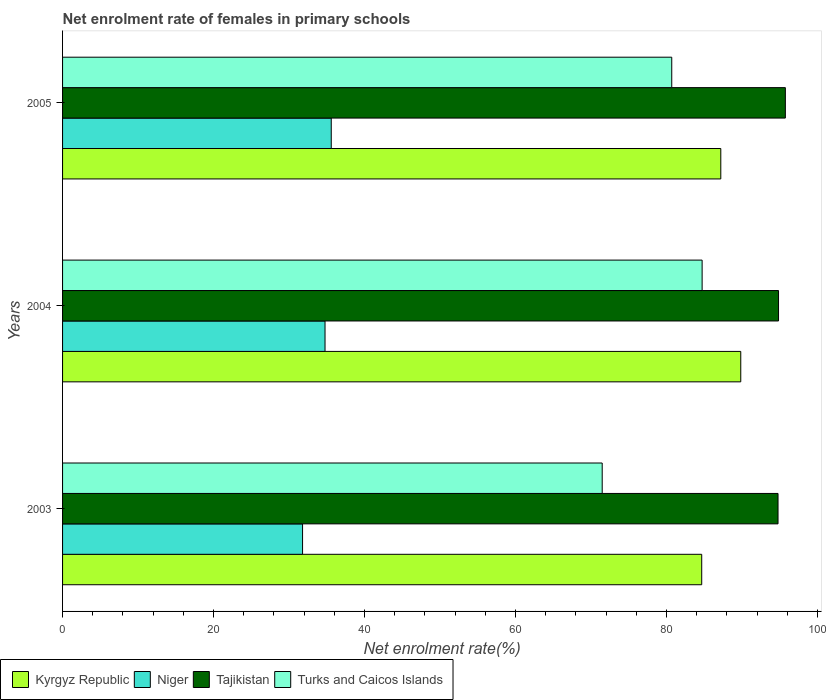How many groups of bars are there?
Keep it short and to the point. 3. Are the number of bars per tick equal to the number of legend labels?
Provide a short and direct response. Yes. What is the net enrolment rate of females in primary schools in Tajikistan in 2005?
Ensure brevity in your answer.  95.74. Across all years, what is the maximum net enrolment rate of females in primary schools in Turks and Caicos Islands?
Ensure brevity in your answer.  84.72. Across all years, what is the minimum net enrolment rate of females in primary schools in Kyrgyz Republic?
Your answer should be compact. 84.66. In which year was the net enrolment rate of females in primary schools in Turks and Caicos Islands minimum?
Ensure brevity in your answer.  2003. What is the total net enrolment rate of females in primary schools in Tajikistan in the graph?
Ensure brevity in your answer.  285.35. What is the difference between the net enrolment rate of females in primary schools in Kyrgyz Republic in 2004 and that in 2005?
Make the answer very short. 2.65. What is the difference between the net enrolment rate of females in primary schools in Turks and Caicos Islands in 2004 and the net enrolment rate of females in primary schools in Kyrgyz Republic in 2005?
Provide a short and direct response. -2.47. What is the average net enrolment rate of females in primary schools in Tajikistan per year?
Give a very brief answer. 95.12. In the year 2005, what is the difference between the net enrolment rate of females in primary schools in Kyrgyz Republic and net enrolment rate of females in primary schools in Tajikistan?
Your answer should be very brief. -8.55. What is the ratio of the net enrolment rate of females in primary schools in Kyrgyz Republic in 2003 to that in 2004?
Keep it short and to the point. 0.94. Is the difference between the net enrolment rate of females in primary schools in Kyrgyz Republic in 2004 and 2005 greater than the difference between the net enrolment rate of females in primary schools in Tajikistan in 2004 and 2005?
Keep it short and to the point. Yes. What is the difference between the highest and the second highest net enrolment rate of females in primary schools in Tajikistan?
Give a very brief answer. 0.9. What is the difference between the highest and the lowest net enrolment rate of females in primary schools in Tajikistan?
Offer a terse response. 0.97. In how many years, is the net enrolment rate of females in primary schools in Niger greater than the average net enrolment rate of females in primary schools in Niger taken over all years?
Make the answer very short. 2. Is it the case that in every year, the sum of the net enrolment rate of females in primary schools in Turks and Caicos Islands and net enrolment rate of females in primary schools in Kyrgyz Republic is greater than the sum of net enrolment rate of females in primary schools in Niger and net enrolment rate of females in primary schools in Tajikistan?
Give a very brief answer. No. What does the 2nd bar from the top in 2004 represents?
Keep it short and to the point. Tajikistan. What does the 4th bar from the bottom in 2004 represents?
Provide a succinct answer. Turks and Caicos Islands. Are all the bars in the graph horizontal?
Provide a short and direct response. Yes. What is the difference between two consecutive major ticks on the X-axis?
Ensure brevity in your answer.  20. Does the graph contain any zero values?
Keep it short and to the point. No. Does the graph contain grids?
Your answer should be very brief. No. How many legend labels are there?
Provide a succinct answer. 4. What is the title of the graph?
Give a very brief answer. Net enrolment rate of females in primary schools. Does "Lesotho" appear as one of the legend labels in the graph?
Keep it short and to the point. No. What is the label or title of the X-axis?
Your response must be concise. Net enrolment rate(%). What is the label or title of the Y-axis?
Offer a terse response. Years. What is the Net enrolment rate(%) in Kyrgyz Republic in 2003?
Make the answer very short. 84.66. What is the Net enrolment rate(%) in Niger in 2003?
Your response must be concise. 31.79. What is the Net enrolment rate(%) in Tajikistan in 2003?
Keep it short and to the point. 94.77. What is the Net enrolment rate(%) of Turks and Caicos Islands in 2003?
Ensure brevity in your answer.  71.48. What is the Net enrolment rate(%) in Kyrgyz Republic in 2004?
Give a very brief answer. 89.84. What is the Net enrolment rate(%) of Niger in 2004?
Make the answer very short. 34.77. What is the Net enrolment rate(%) in Tajikistan in 2004?
Offer a terse response. 94.84. What is the Net enrolment rate(%) in Turks and Caicos Islands in 2004?
Offer a very short reply. 84.72. What is the Net enrolment rate(%) of Kyrgyz Republic in 2005?
Your answer should be very brief. 87.19. What is the Net enrolment rate(%) of Niger in 2005?
Your answer should be very brief. 35.59. What is the Net enrolment rate(%) of Tajikistan in 2005?
Make the answer very short. 95.74. What is the Net enrolment rate(%) in Turks and Caicos Islands in 2005?
Give a very brief answer. 80.69. Across all years, what is the maximum Net enrolment rate(%) in Kyrgyz Republic?
Your answer should be compact. 89.84. Across all years, what is the maximum Net enrolment rate(%) in Niger?
Provide a succinct answer. 35.59. Across all years, what is the maximum Net enrolment rate(%) in Tajikistan?
Your answer should be very brief. 95.74. Across all years, what is the maximum Net enrolment rate(%) in Turks and Caicos Islands?
Offer a very short reply. 84.72. Across all years, what is the minimum Net enrolment rate(%) of Kyrgyz Republic?
Provide a short and direct response. 84.66. Across all years, what is the minimum Net enrolment rate(%) in Niger?
Offer a terse response. 31.79. Across all years, what is the minimum Net enrolment rate(%) in Tajikistan?
Provide a succinct answer. 94.77. Across all years, what is the minimum Net enrolment rate(%) in Turks and Caicos Islands?
Offer a very short reply. 71.48. What is the total Net enrolment rate(%) of Kyrgyz Republic in the graph?
Your answer should be very brief. 261.69. What is the total Net enrolment rate(%) in Niger in the graph?
Your answer should be compact. 102.15. What is the total Net enrolment rate(%) in Tajikistan in the graph?
Ensure brevity in your answer.  285.35. What is the total Net enrolment rate(%) of Turks and Caicos Islands in the graph?
Your answer should be compact. 236.89. What is the difference between the Net enrolment rate(%) in Kyrgyz Republic in 2003 and that in 2004?
Your response must be concise. -5.17. What is the difference between the Net enrolment rate(%) in Niger in 2003 and that in 2004?
Ensure brevity in your answer.  -2.98. What is the difference between the Net enrolment rate(%) in Tajikistan in 2003 and that in 2004?
Your answer should be compact. -0.07. What is the difference between the Net enrolment rate(%) in Turks and Caicos Islands in 2003 and that in 2004?
Ensure brevity in your answer.  -13.24. What is the difference between the Net enrolment rate(%) of Kyrgyz Republic in 2003 and that in 2005?
Your answer should be compact. -2.53. What is the difference between the Net enrolment rate(%) of Niger in 2003 and that in 2005?
Offer a terse response. -3.8. What is the difference between the Net enrolment rate(%) in Tajikistan in 2003 and that in 2005?
Provide a succinct answer. -0.97. What is the difference between the Net enrolment rate(%) of Turks and Caicos Islands in 2003 and that in 2005?
Your response must be concise. -9.21. What is the difference between the Net enrolment rate(%) of Kyrgyz Republic in 2004 and that in 2005?
Your answer should be compact. 2.65. What is the difference between the Net enrolment rate(%) in Niger in 2004 and that in 2005?
Make the answer very short. -0.82. What is the difference between the Net enrolment rate(%) in Tajikistan in 2004 and that in 2005?
Your response must be concise. -0.9. What is the difference between the Net enrolment rate(%) of Turks and Caicos Islands in 2004 and that in 2005?
Your response must be concise. 4.02. What is the difference between the Net enrolment rate(%) in Kyrgyz Republic in 2003 and the Net enrolment rate(%) in Niger in 2004?
Your response must be concise. 49.9. What is the difference between the Net enrolment rate(%) of Kyrgyz Republic in 2003 and the Net enrolment rate(%) of Tajikistan in 2004?
Keep it short and to the point. -10.18. What is the difference between the Net enrolment rate(%) in Kyrgyz Republic in 2003 and the Net enrolment rate(%) in Turks and Caicos Islands in 2004?
Offer a very short reply. -0.05. What is the difference between the Net enrolment rate(%) of Niger in 2003 and the Net enrolment rate(%) of Tajikistan in 2004?
Provide a short and direct response. -63.05. What is the difference between the Net enrolment rate(%) in Niger in 2003 and the Net enrolment rate(%) in Turks and Caicos Islands in 2004?
Your answer should be very brief. -52.93. What is the difference between the Net enrolment rate(%) of Tajikistan in 2003 and the Net enrolment rate(%) of Turks and Caicos Islands in 2004?
Make the answer very short. 10.06. What is the difference between the Net enrolment rate(%) in Kyrgyz Republic in 2003 and the Net enrolment rate(%) in Niger in 2005?
Keep it short and to the point. 49.07. What is the difference between the Net enrolment rate(%) of Kyrgyz Republic in 2003 and the Net enrolment rate(%) of Tajikistan in 2005?
Ensure brevity in your answer.  -11.08. What is the difference between the Net enrolment rate(%) in Kyrgyz Republic in 2003 and the Net enrolment rate(%) in Turks and Caicos Islands in 2005?
Make the answer very short. 3.97. What is the difference between the Net enrolment rate(%) of Niger in 2003 and the Net enrolment rate(%) of Tajikistan in 2005?
Provide a succinct answer. -63.95. What is the difference between the Net enrolment rate(%) in Niger in 2003 and the Net enrolment rate(%) in Turks and Caicos Islands in 2005?
Ensure brevity in your answer.  -48.9. What is the difference between the Net enrolment rate(%) in Tajikistan in 2003 and the Net enrolment rate(%) in Turks and Caicos Islands in 2005?
Provide a succinct answer. 14.08. What is the difference between the Net enrolment rate(%) in Kyrgyz Republic in 2004 and the Net enrolment rate(%) in Niger in 2005?
Offer a very short reply. 54.25. What is the difference between the Net enrolment rate(%) of Kyrgyz Republic in 2004 and the Net enrolment rate(%) of Tajikistan in 2005?
Offer a very short reply. -5.91. What is the difference between the Net enrolment rate(%) in Kyrgyz Republic in 2004 and the Net enrolment rate(%) in Turks and Caicos Islands in 2005?
Offer a terse response. 9.14. What is the difference between the Net enrolment rate(%) of Niger in 2004 and the Net enrolment rate(%) of Tajikistan in 2005?
Provide a short and direct response. -60.98. What is the difference between the Net enrolment rate(%) in Niger in 2004 and the Net enrolment rate(%) in Turks and Caicos Islands in 2005?
Give a very brief answer. -45.93. What is the difference between the Net enrolment rate(%) in Tajikistan in 2004 and the Net enrolment rate(%) in Turks and Caicos Islands in 2005?
Your answer should be very brief. 14.14. What is the average Net enrolment rate(%) of Kyrgyz Republic per year?
Provide a short and direct response. 87.23. What is the average Net enrolment rate(%) in Niger per year?
Your answer should be very brief. 34.05. What is the average Net enrolment rate(%) in Tajikistan per year?
Ensure brevity in your answer.  95.12. What is the average Net enrolment rate(%) in Turks and Caicos Islands per year?
Provide a short and direct response. 78.96. In the year 2003, what is the difference between the Net enrolment rate(%) of Kyrgyz Republic and Net enrolment rate(%) of Niger?
Make the answer very short. 52.87. In the year 2003, what is the difference between the Net enrolment rate(%) in Kyrgyz Republic and Net enrolment rate(%) in Tajikistan?
Provide a short and direct response. -10.11. In the year 2003, what is the difference between the Net enrolment rate(%) of Kyrgyz Republic and Net enrolment rate(%) of Turks and Caicos Islands?
Offer a very short reply. 13.18. In the year 2003, what is the difference between the Net enrolment rate(%) in Niger and Net enrolment rate(%) in Tajikistan?
Ensure brevity in your answer.  -62.98. In the year 2003, what is the difference between the Net enrolment rate(%) of Niger and Net enrolment rate(%) of Turks and Caicos Islands?
Provide a short and direct response. -39.69. In the year 2003, what is the difference between the Net enrolment rate(%) of Tajikistan and Net enrolment rate(%) of Turks and Caicos Islands?
Keep it short and to the point. 23.29. In the year 2004, what is the difference between the Net enrolment rate(%) in Kyrgyz Republic and Net enrolment rate(%) in Niger?
Offer a terse response. 55.07. In the year 2004, what is the difference between the Net enrolment rate(%) of Kyrgyz Republic and Net enrolment rate(%) of Tajikistan?
Your answer should be very brief. -5. In the year 2004, what is the difference between the Net enrolment rate(%) in Kyrgyz Republic and Net enrolment rate(%) in Turks and Caicos Islands?
Offer a terse response. 5.12. In the year 2004, what is the difference between the Net enrolment rate(%) of Niger and Net enrolment rate(%) of Tajikistan?
Give a very brief answer. -60.07. In the year 2004, what is the difference between the Net enrolment rate(%) of Niger and Net enrolment rate(%) of Turks and Caicos Islands?
Provide a succinct answer. -49.95. In the year 2004, what is the difference between the Net enrolment rate(%) of Tajikistan and Net enrolment rate(%) of Turks and Caicos Islands?
Make the answer very short. 10.12. In the year 2005, what is the difference between the Net enrolment rate(%) of Kyrgyz Republic and Net enrolment rate(%) of Niger?
Keep it short and to the point. 51.6. In the year 2005, what is the difference between the Net enrolment rate(%) of Kyrgyz Republic and Net enrolment rate(%) of Tajikistan?
Offer a terse response. -8.55. In the year 2005, what is the difference between the Net enrolment rate(%) of Kyrgyz Republic and Net enrolment rate(%) of Turks and Caicos Islands?
Keep it short and to the point. 6.5. In the year 2005, what is the difference between the Net enrolment rate(%) of Niger and Net enrolment rate(%) of Tajikistan?
Offer a terse response. -60.15. In the year 2005, what is the difference between the Net enrolment rate(%) in Niger and Net enrolment rate(%) in Turks and Caicos Islands?
Your answer should be compact. -45.1. In the year 2005, what is the difference between the Net enrolment rate(%) of Tajikistan and Net enrolment rate(%) of Turks and Caicos Islands?
Offer a very short reply. 15.05. What is the ratio of the Net enrolment rate(%) of Kyrgyz Republic in 2003 to that in 2004?
Your answer should be very brief. 0.94. What is the ratio of the Net enrolment rate(%) in Niger in 2003 to that in 2004?
Your response must be concise. 0.91. What is the ratio of the Net enrolment rate(%) in Turks and Caicos Islands in 2003 to that in 2004?
Offer a terse response. 0.84. What is the ratio of the Net enrolment rate(%) in Niger in 2003 to that in 2005?
Provide a short and direct response. 0.89. What is the ratio of the Net enrolment rate(%) in Turks and Caicos Islands in 2003 to that in 2005?
Ensure brevity in your answer.  0.89. What is the ratio of the Net enrolment rate(%) of Kyrgyz Republic in 2004 to that in 2005?
Offer a very short reply. 1.03. What is the ratio of the Net enrolment rate(%) of Niger in 2004 to that in 2005?
Give a very brief answer. 0.98. What is the ratio of the Net enrolment rate(%) in Tajikistan in 2004 to that in 2005?
Provide a short and direct response. 0.99. What is the ratio of the Net enrolment rate(%) of Turks and Caicos Islands in 2004 to that in 2005?
Offer a very short reply. 1.05. What is the difference between the highest and the second highest Net enrolment rate(%) of Kyrgyz Republic?
Give a very brief answer. 2.65. What is the difference between the highest and the second highest Net enrolment rate(%) of Niger?
Offer a terse response. 0.82. What is the difference between the highest and the second highest Net enrolment rate(%) in Tajikistan?
Your response must be concise. 0.9. What is the difference between the highest and the second highest Net enrolment rate(%) in Turks and Caicos Islands?
Keep it short and to the point. 4.02. What is the difference between the highest and the lowest Net enrolment rate(%) of Kyrgyz Republic?
Keep it short and to the point. 5.17. What is the difference between the highest and the lowest Net enrolment rate(%) in Niger?
Provide a short and direct response. 3.8. What is the difference between the highest and the lowest Net enrolment rate(%) of Tajikistan?
Ensure brevity in your answer.  0.97. What is the difference between the highest and the lowest Net enrolment rate(%) of Turks and Caicos Islands?
Ensure brevity in your answer.  13.24. 